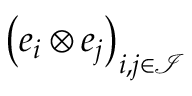Convert formula to latex. <formula><loc_0><loc_0><loc_500><loc_500>\left ( e _ { i } \otimes e _ { j } \right ) _ { i , j \in \mathcal { I } }</formula> 